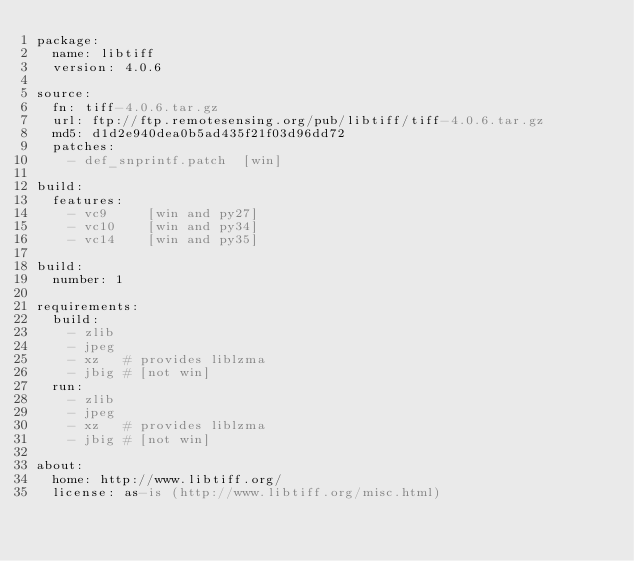Convert code to text. <code><loc_0><loc_0><loc_500><loc_500><_YAML_>package:
  name: libtiff
  version: 4.0.6

source:
  fn: tiff-4.0.6.tar.gz
  url: ftp://ftp.remotesensing.org/pub/libtiff/tiff-4.0.6.tar.gz
  md5: d1d2e940dea0b5ad435f21f03d96dd72
  patches:
    - def_snprintf.patch  [win]

build:
  features:
    - vc9     [win and py27]
    - vc10    [win and py34]
    - vc14    [win and py35]

build:
  number: 1

requirements:
  build:
    - zlib
    - jpeg
    - xz   # provides liblzma
    - jbig # [not win]
  run:
    - zlib
    - jpeg
    - xz   # provides liblzma
    - jbig # [not win]

about:
  home: http://www.libtiff.org/
  license: as-is (http://www.libtiff.org/misc.html)
</code> 